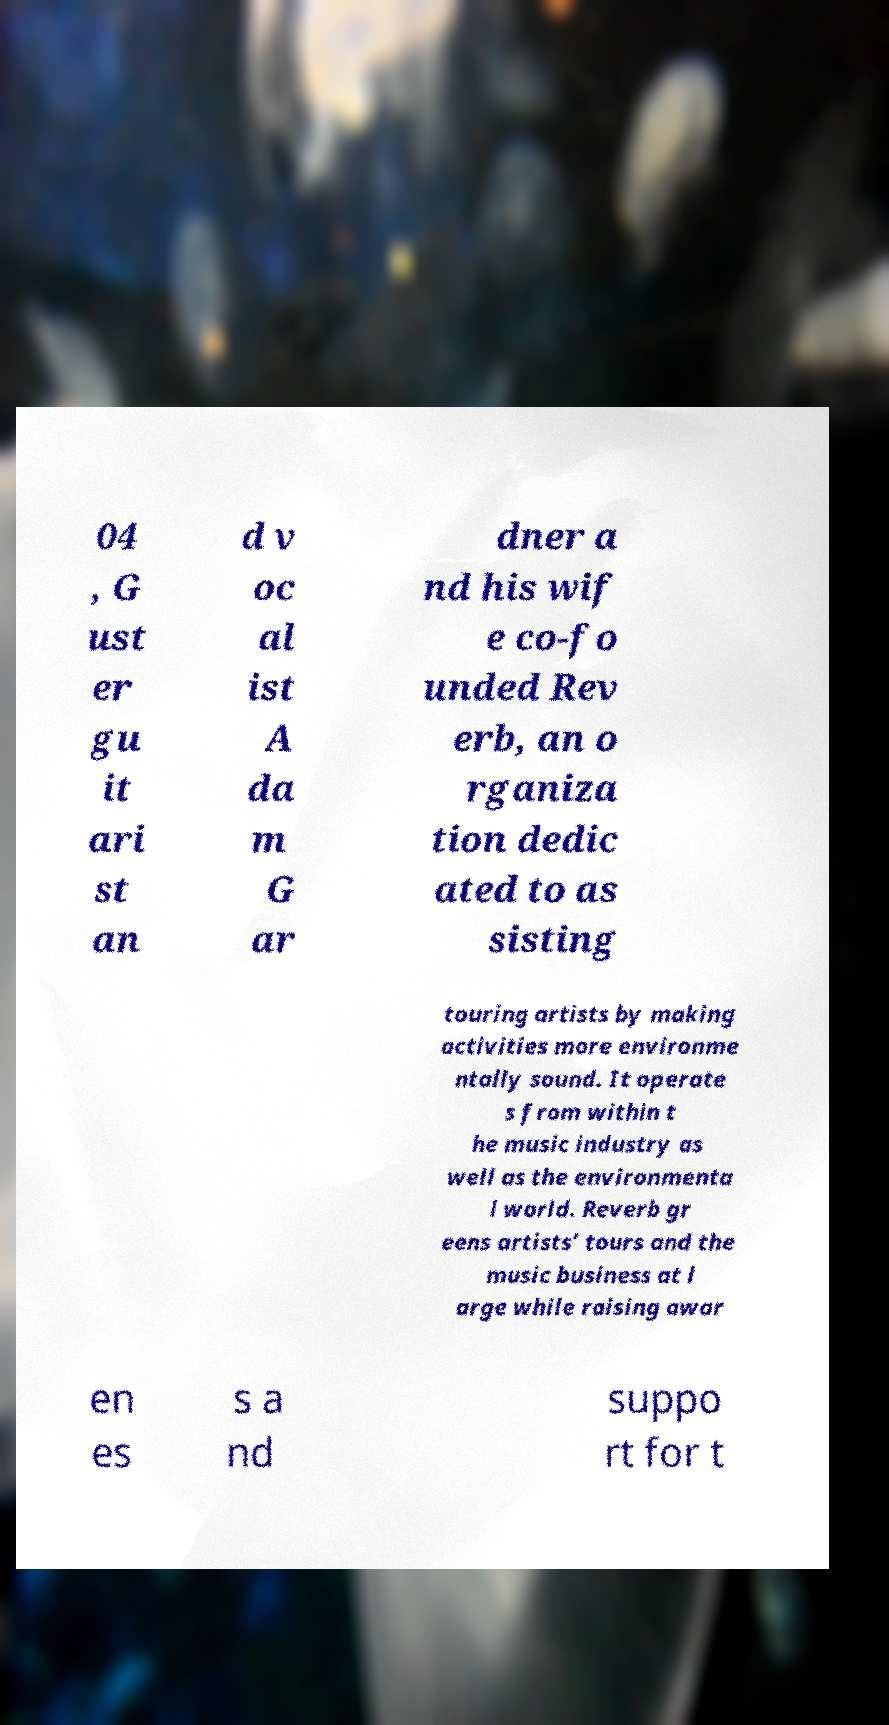Could you assist in decoding the text presented in this image and type it out clearly? 04 , G ust er gu it ari st an d v oc al ist A da m G ar dner a nd his wif e co-fo unded Rev erb, an o rganiza tion dedic ated to as sisting touring artists by making activities more environme ntally sound. It operate s from within t he music industry as well as the environmenta l world. Reverb gr eens artists’ tours and the music business at l arge while raising awar en es s a nd suppo rt for t 